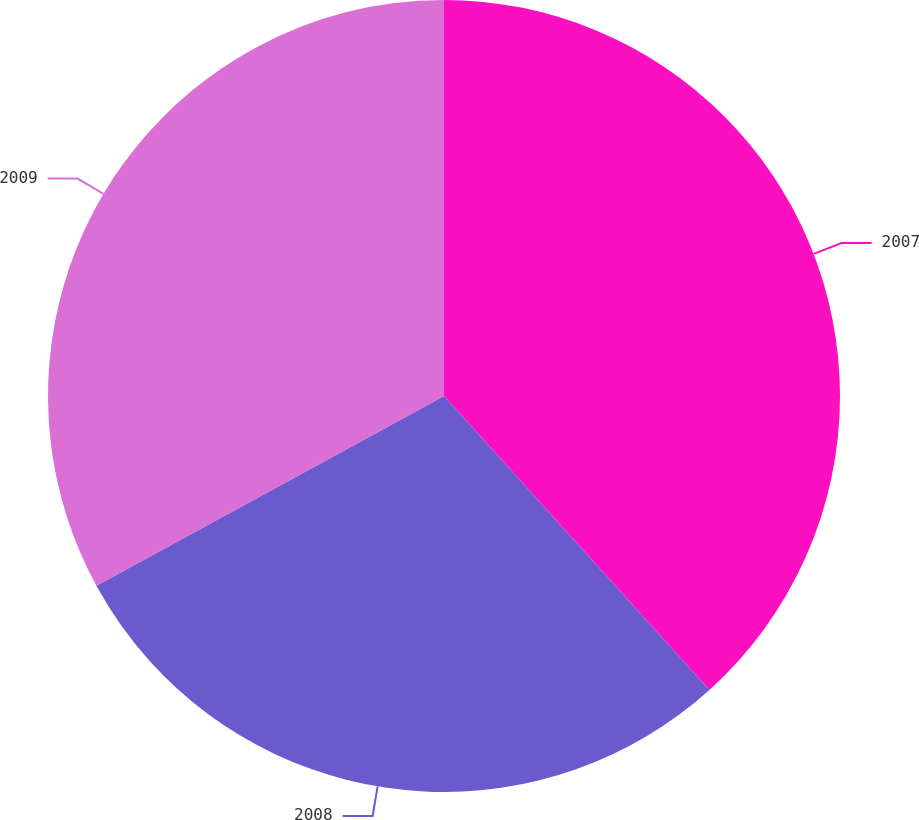<chart> <loc_0><loc_0><loc_500><loc_500><pie_chart><fcel>2007<fcel>2008<fcel>2009<nl><fcel>38.31%<fcel>28.74%<fcel>32.95%<nl></chart> 